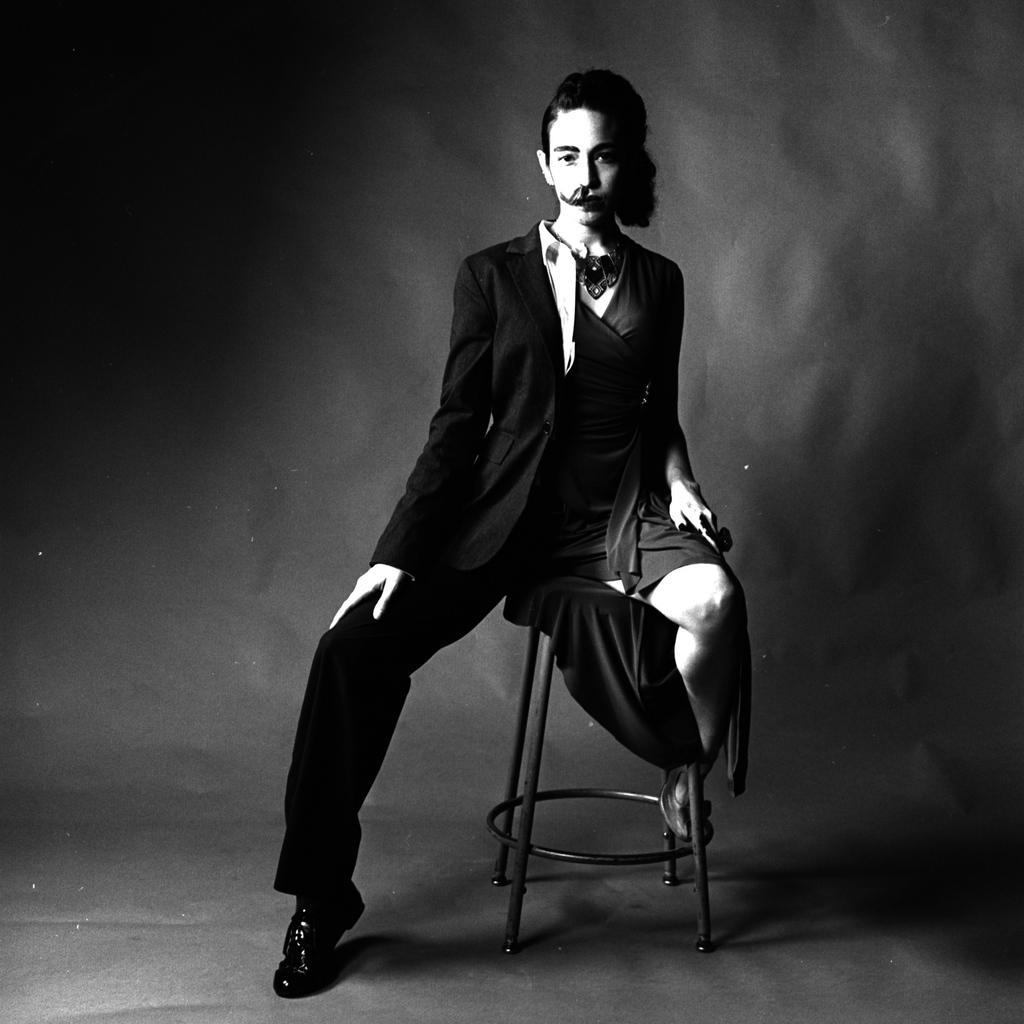Describe this image in one or two sentences. In this picture we can see a person dressed up half as a man and half as a woman and sitting on a stool. Behind the person there is a dark background. 